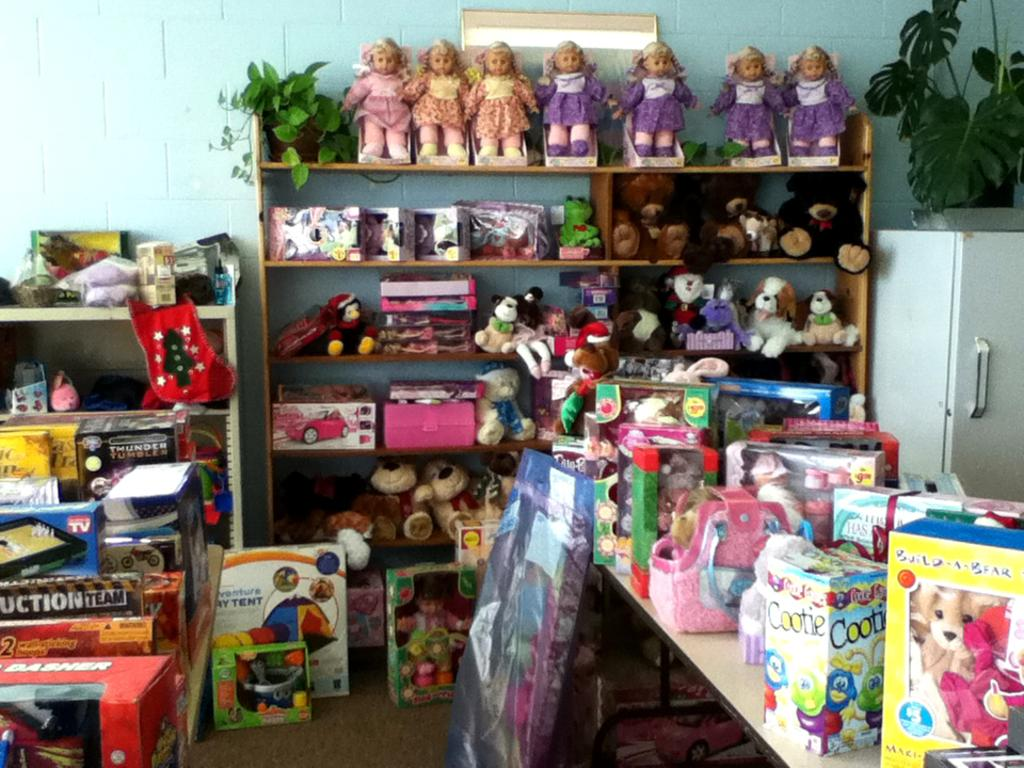<image>
Share a concise interpretation of the image provided. A box holding a Cootie toy sits in a store surrounded by many other toys. 